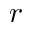<formula> <loc_0><loc_0><loc_500><loc_500>r</formula> 